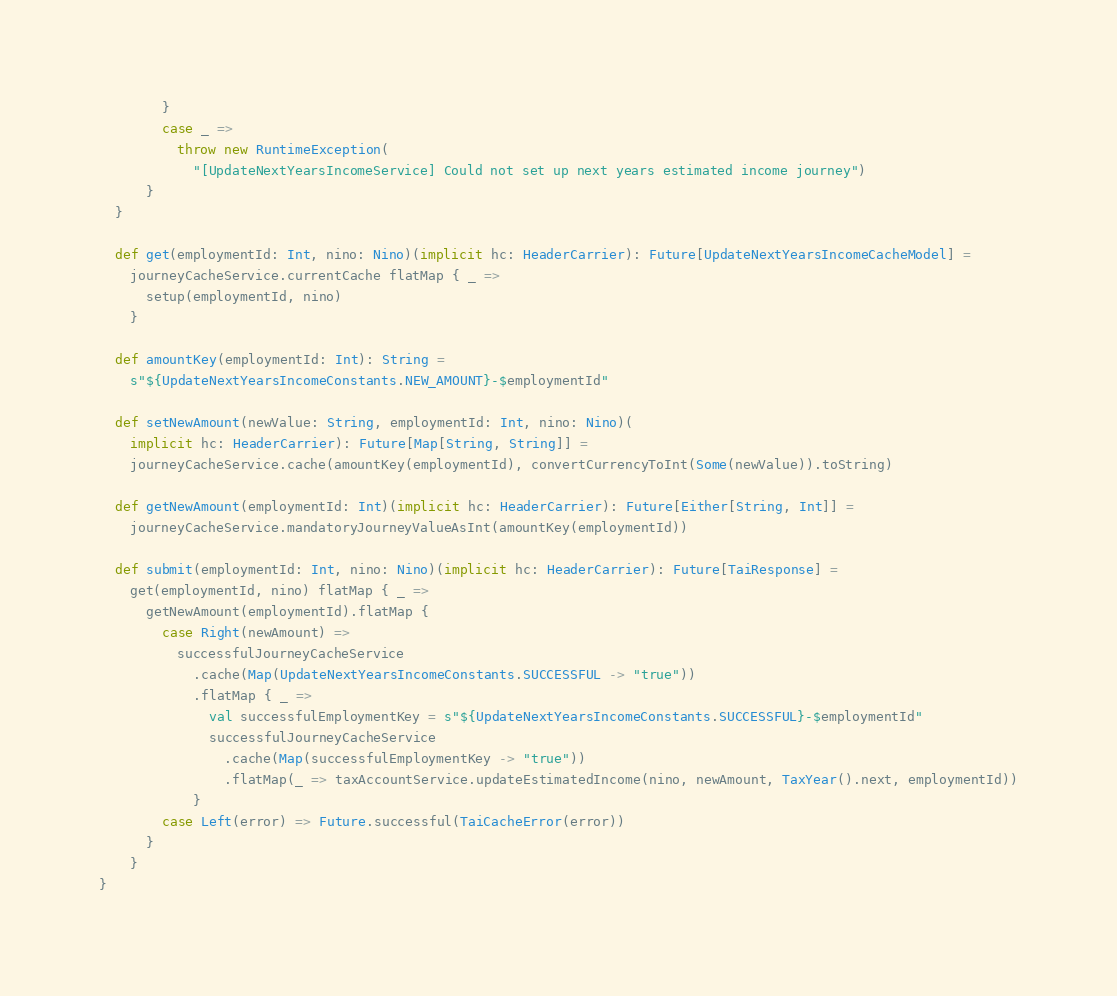Convert code to text. <code><loc_0><loc_0><loc_500><loc_500><_Scala_>        }
        case _ =>
          throw new RuntimeException(
            "[UpdateNextYearsIncomeService] Could not set up next years estimated income journey")
      }
  }

  def get(employmentId: Int, nino: Nino)(implicit hc: HeaderCarrier): Future[UpdateNextYearsIncomeCacheModel] =
    journeyCacheService.currentCache flatMap { _ =>
      setup(employmentId, nino)
    }

  def amountKey(employmentId: Int): String =
    s"${UpdateNextYearsIncomeConstants.NEW_AMOUNT}-$employmentId"

  def setNewAmount(newValue: String, employmentId: Int, nino: Nino)(
    implicit hc: HeaderCarrier): Future[Map[String, String]] =
    journeyCacheService.cache(amountKey(employmentId), convertCurrencyToInt(Some(newValue)).toString)

  def getNewAmount(employmentId: Int)(implicit hc: HeaderCarrier): Future[Either[String, Int]] =
    journeyCacheService.mandatoryJourneyValueAsInt(amountKey(employmentId))

  def submit(employmentId: Int, nino: Nino)(implicit hc: HeaderCarrier): Future[TaiResponse] =
    get(employmentId, nino) flatMap { _ =>
      getNewAmount(employmentId).flatMap {
        case Right(newAmount) =>
          successfulJourneyCacheService
            .cache(Map(UpdateNextYearsIncomeConstants.SUCCESSFUL -> "true"))
            .flatMap { _ =>
              val successfulEmploymentKey = s"${UpdateNextYearsIncomeConstants.SUCCESSFUL}-$employmentId"
              successfulJourneyCacheService
                .cache(Map(successfulEmploymentKey -> "true"))
                .flatMap(_ => taxAccountService.updateEstimatedIncome(nino, newAmount, TaxYear().next, employmentId))
            }
        case Left(error) => Future.successful(TaiCacheError(error))
      }
    }
}
</code> 